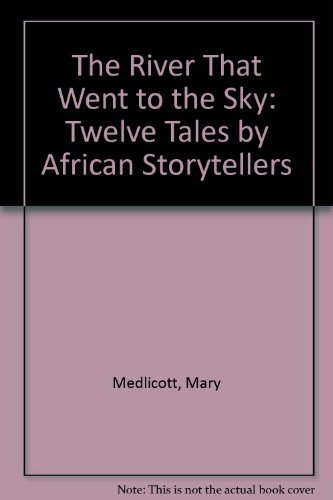Is this an exam preparation book? No, this book is not intended for exam preparation; rather, it offers creative stories for recreational reading and cultural learning. 